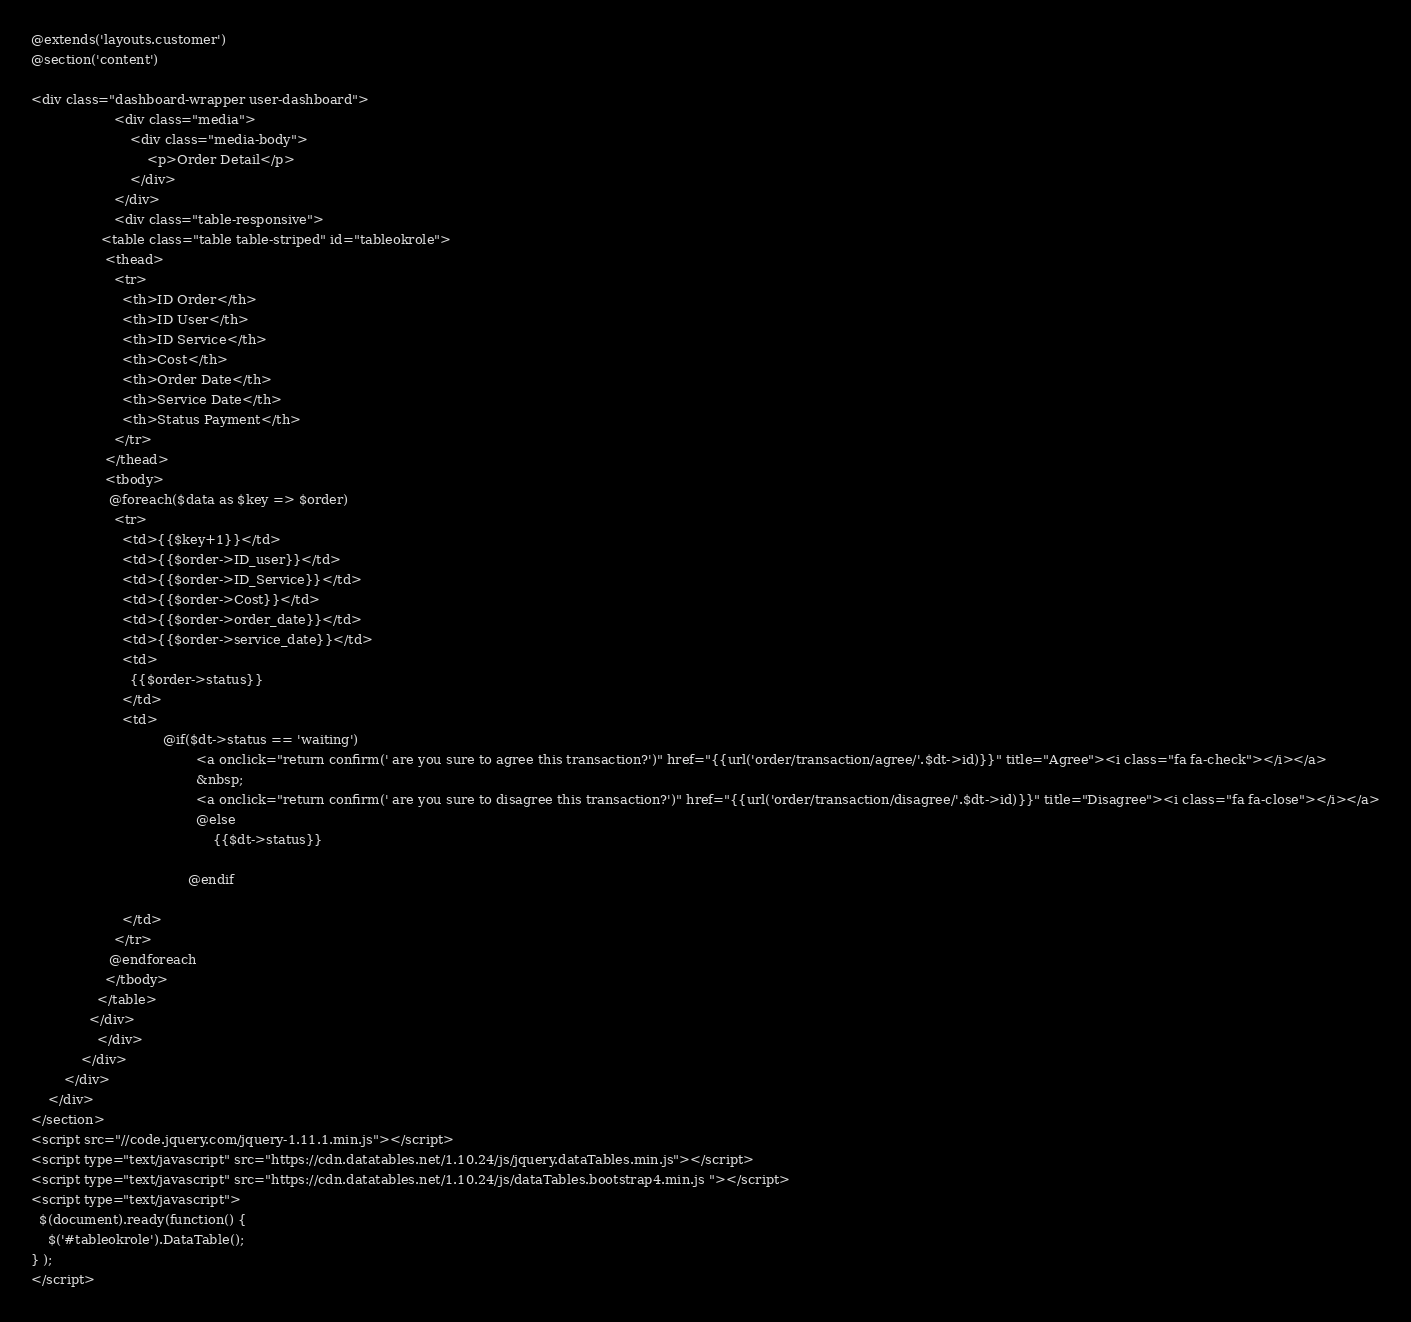<code> <loc_0><loc_0><loc_500><loc_500><_PHP_>@extends('layouts.customer')
@section('content')

<div class="dashboard-wrapper user-dashboard">
					<div class="media">
						<div class="media-body">
							<p>Order Detail</p>
						</div>
					</div>
					<div class="table-responsive">
				 <table class="table table-striped" id="tableokrole">
                  <thead>
                    <tr>
                      <th>ID Order</th>
                      <th>ID User</th>
                      <th>ID Service</th>
                      <th>Cost</th>
                      <th>Order Date</th>
                      <th>Service Date</th>
                      <th>Status Payment</th>
                    </tr>
                  </thead>
                  <tbody>
                   @foreach($data as $key => $order)
                    <tr>
                      <td>{{$key+1}}</td>
                      <td>{{$order->ID_user}}</td>
                      <td>{{$order->ID_Service}}</td>
                      <td>{{$order->Cost}}</td>
                      <td>{{$order->order_date}}</td>
                      <td>{{$order->service_date}}</td>
                      <td>
                        {{$order->status}}
                      </td>
                      <td>
                            	@if($dt->status == 'waiting')
				                      	<a onclick="return confirm(' are you sure to agree this transaction?')" href="{{url('order/transaction/agree/'.$dt->id)}}" title="Agree"><i class="fa fa-check"></i></a>
				                      	&nbsp;
				                      	<a onclick="return confirm(' are you sure to disagree this transaction?')" href="{{url('order/transaction/disagree/'.$dt->id)}}" title="Disagree"><i class="fa fa-close"></i></a>
				                      	@else
				                      		{{$dt->status}}
				                      	
				                      @endif

                      </td> 
                    </tr>
                   @endforeach
                  </tbody>
                </table>
              </div>
				</div>
			</div>
		</div>
	</div>
</section>
<script src="//code.jquery.com/jquery-1.11.1.min.js"></script>
<script type="text/javascript" src="https://cdn.datatables.net/1.10.24/js/jquery.dataTables.min.js"></script>
<script type="text/javascript" src="https://cdn.datatables.net/1.10.24/js/dataTables.bootstrap4.min.js "></script>
<script type="text/javascript">
  $(document).ready(function() {
    $('#tableokrole').DataTable();
} );
</script></code> 